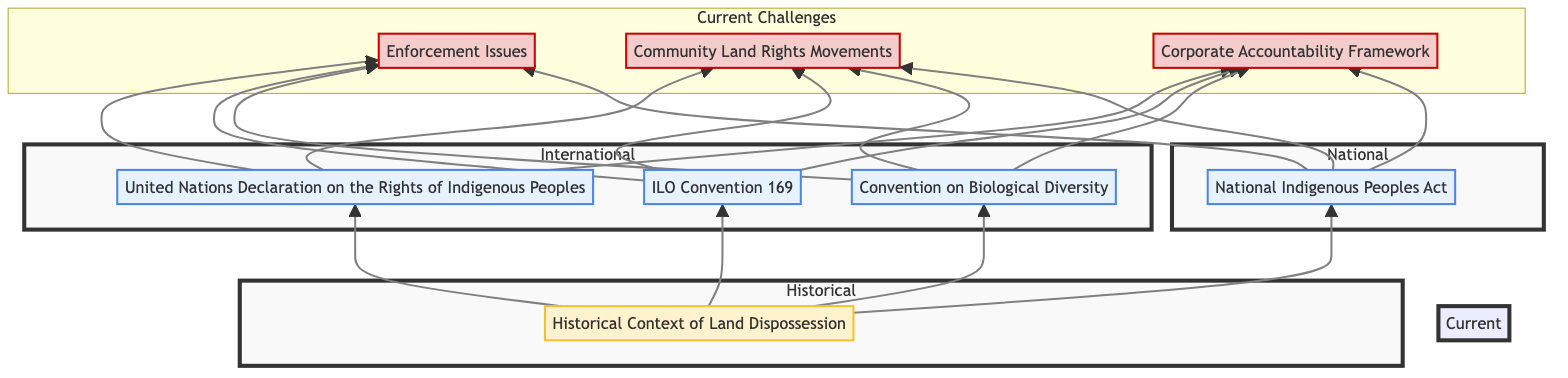What legislation affirms the rights of indigenous peoples to their land? The diagram shows that the United Nations Declaration on the Rights of Indigenous Peoples is specifically identified as legislation that affirms indigenous peoples' rights to land, territories, and resources.
Answer: United Nations Declaration on the Rights of Indigenous Peoples How many elements are in the Current Challenges section? Upon examination of the diagram, the Current Challenges section contains three key elements: Enforcement Issues, Community Land Rights Movements, and Corporate Accountability Framework.
Answer: 3 Which act provides rights to indigenous peoples at a national level? The diagram indicates that the National Indigenous Peoples Act is the legislation that provides rights to indigenous peoples, reflecting its status within the National subgraph.
Answer: National Indigenous Peoples Act What historical context influences the current legal frameworks for indigenous rights? The diagram explicitly references the Historical Context of Land Dispossession as the key historical context that influences current rights frameworks, showing a direct connection.
Answer: Historical Context of Land Dispossession What connects the Historical Context of Land Dispossession to the legislations? The arrows in the diagram show a directional connection from the Historical Context of Land Dispossession to each of the legislation elements (UNDRIP, ILO Convention 169, CBD, National Indigenous Peoples Act), indicating that history influences these laws.
Answer: Legislation Which legislation recognizes the rights of indigenous and tribal peoples, including their right to consultation? According to the diagram, the ILO Convention 169 is specifically identified as the legislation that recognizes the rights of indigenous and tribal peoples, including consultation rights.
Answer: ILO Convention 169 What ongoing challenge is related to inadequate implementation of laws? The diagram names Enforcement Issues as a current challenge that directly ties to inadequate implementation of laws regarding indigenous rights.
Answer: Enforcement Issues What type of node does the Community Land Rights Movements belong to? The diagram categorizes Community Land Rights Movements as a challenge, based on its visual representation within the Current Challenges section.
Answer: Challenge 